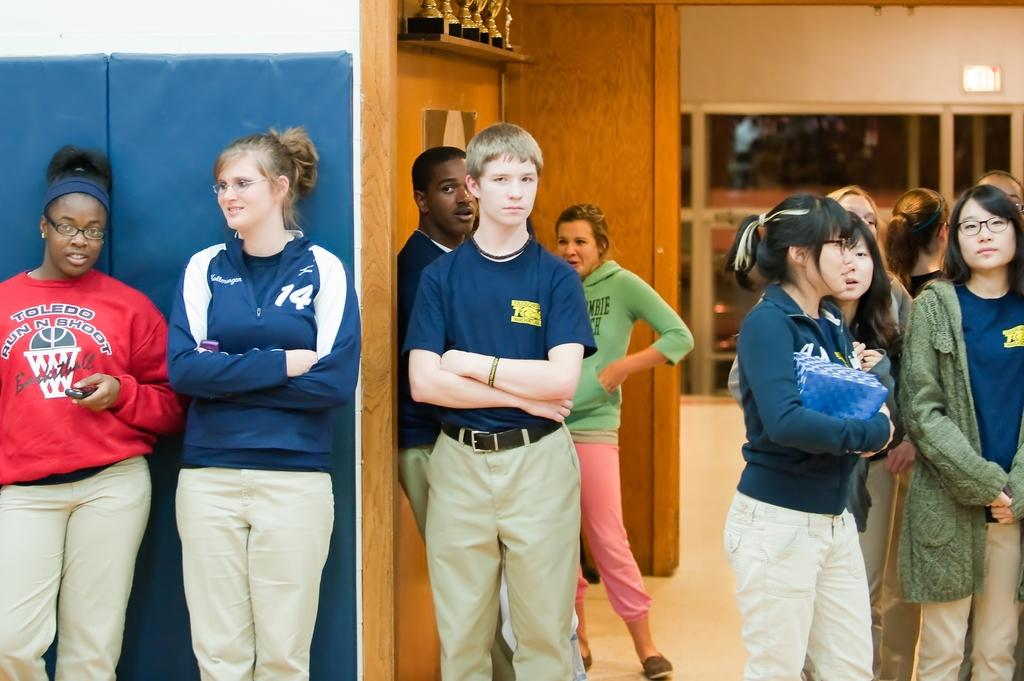What type of structure can be seen in the image? There is a wall in the image. Who or what is present in the image? There are people in the image. What feature allows light and air into the space? There is a window in the image. What type of protective gear is visible in the image? There are shields in the image. What type of linen is draped over the shields in the image? There is no linen draped over the shields in the image; the shields are visible as they are. How many arms are visible in the image? The provided facts do not mention any specific number of arms or limbs visible in the image. 